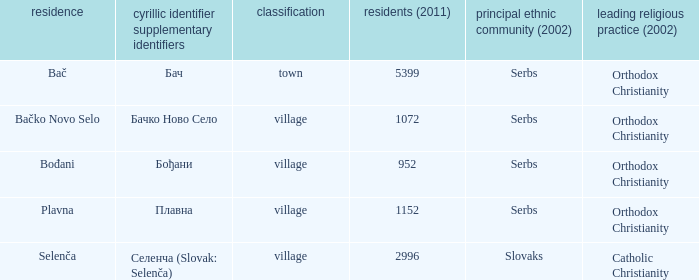What is the ethnic majority in the only town? Serbs. 